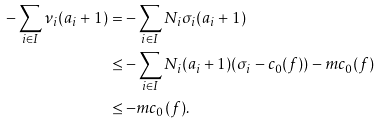Convert formula to latex. <formula><loc_0><loc_0><loc_500><loc_500>- \sum _ { i \in I } \nu _ { i } ( a _ { i } + 1 ) & = - \sum _ { i \in I } N _ { i } \sigma _ { i } ( a _ { i } + 1 ) \\ & \leq - \sum _ { i \in I } N _ { i } ( a _ { i } + 1 ) ( \sigma _ { i } - c _ { 0 } ( f ) ) - m c _ { 0 } ( f ) \\ & \leq - m c _ { 0 } ( f ) .</formula> 